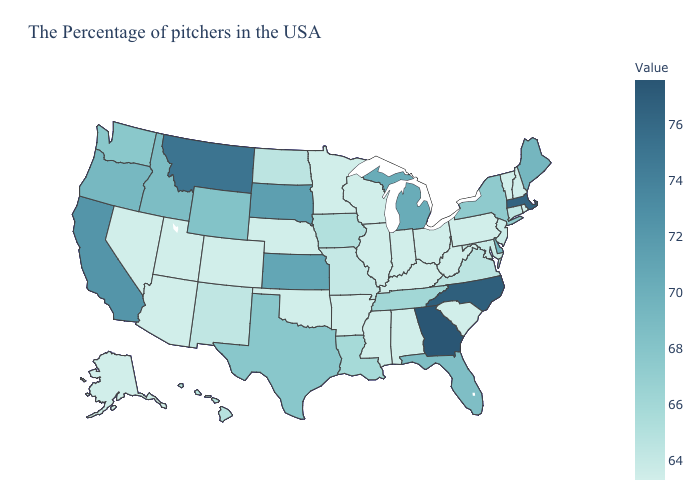Which states have the lowest value in the USA?
Be succinct. Rhode Island, New Hampshire, Vermont, Pennsylvania, South Carolina, West Virginia, Ohio, Kentucky, Indiana, Alabama, Wisconsin, Illinois, Mississippi, Arkansas, Minnesota, Nebraska, Oklahoma, Colorado, Utah, Arizona, Nevada, Alaska. Among the states that border Oklahoma , which have the lowest value?
Write a very short answer. Arkansas, Colorado. Among the states that border Idaho , does Washington have the highest value?
Quick response, please. No. Among the states that border Maryland , does Pennsylvania have the lowest value?
Write a very short answer. Yes. Does Rhode Island have the lowest value in the USA?
Keep it brief. Yes. Which states hav the highest value in the West?
Write a very short answer. Montana. 